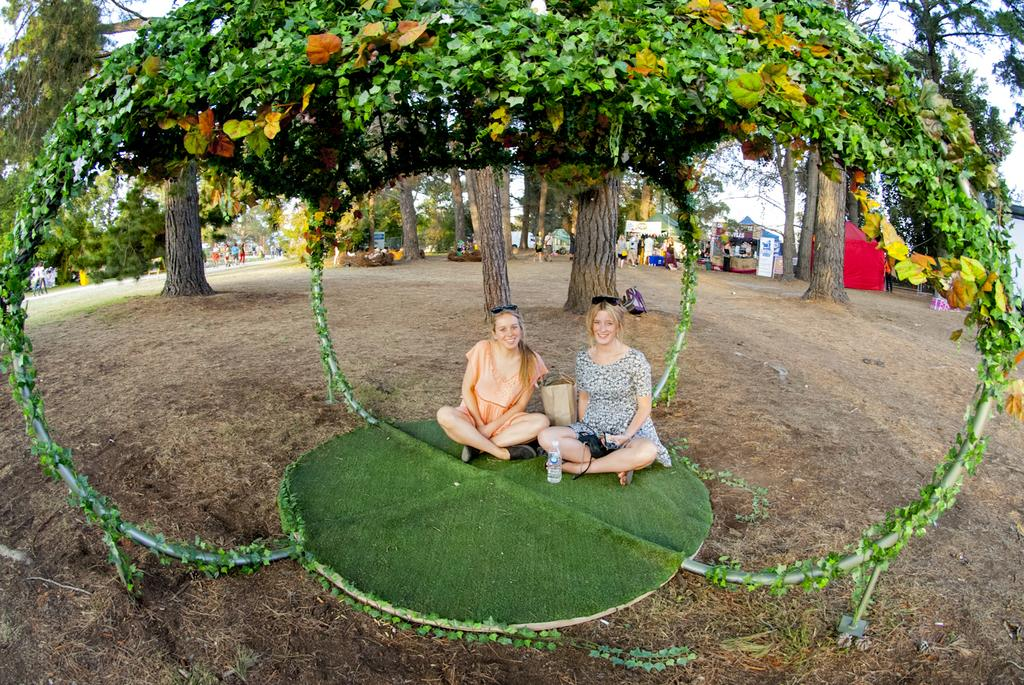How many women are in the image? There are two women in the image. What are the women sitting on? The women are sitting on a green mat. What is located above the women? There are plants above the women. What can be seen in the background of the image? There are trees and the sky visible in the background of the image. What type of chalk is the woman on the left using to draw on the mat? There is no chalk present in the image, and the women are not drawing on the mat. 